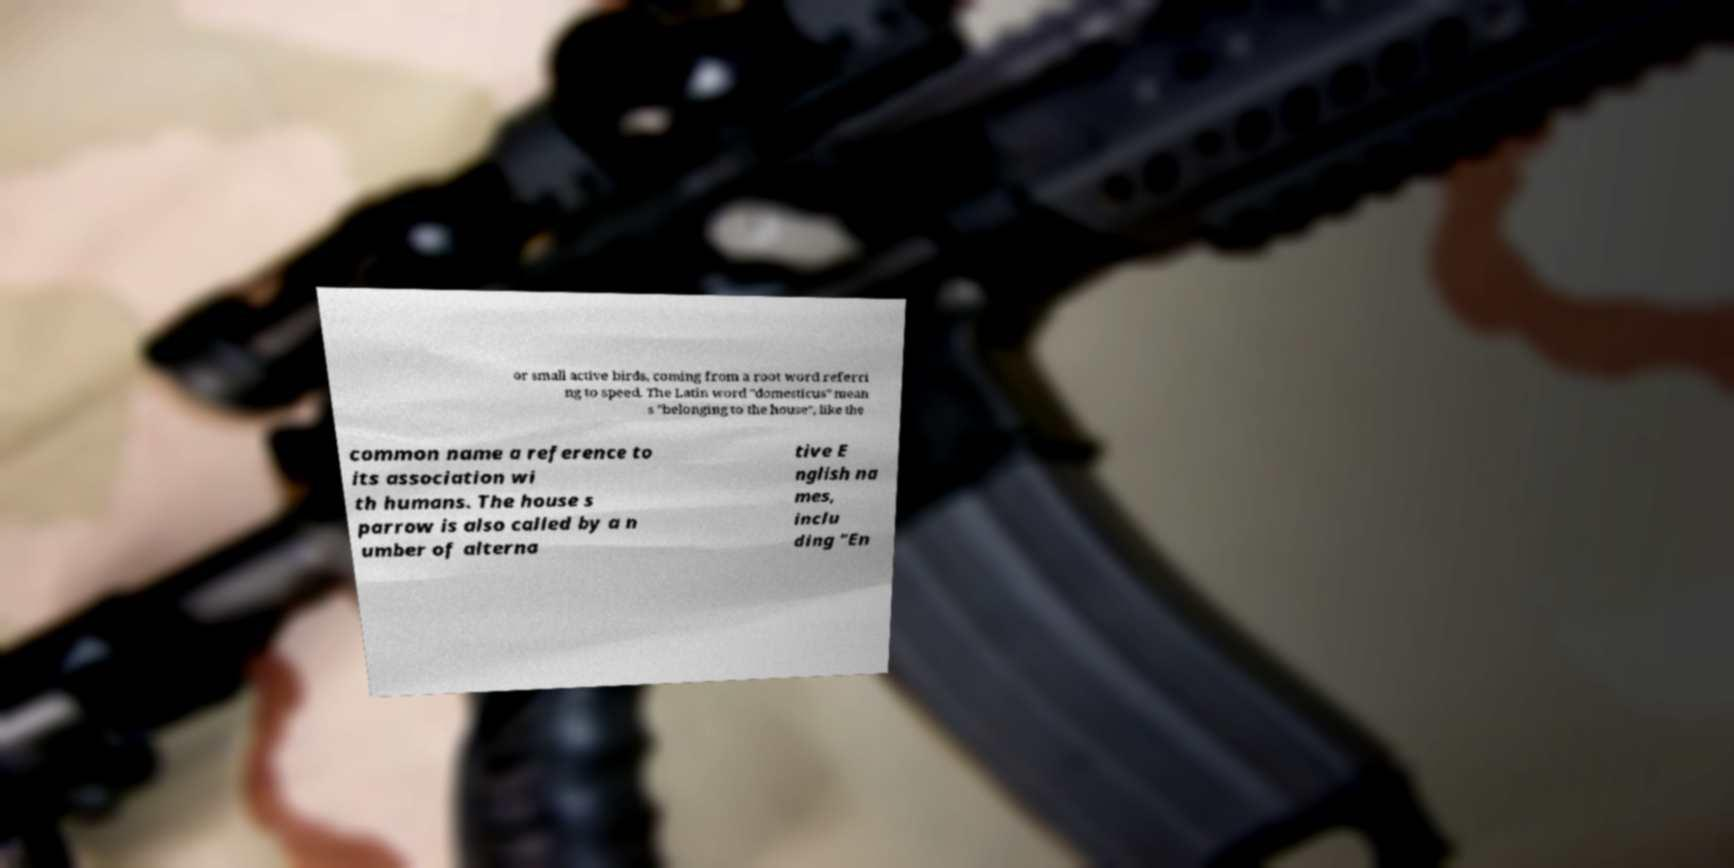What messages or text are displayed in this image? I need them in a readable, typed format. or small active birds, coming from a root word referri ng to speed. The Latin word "domesticus" mean s "belonging to the house", like the common name a reference to its association wi th humans. The house s parrow is also called by a n umber of alterna tive E nglish na mes, inclu ding "En 